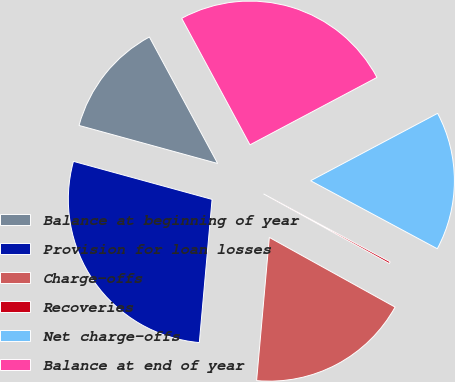Convert chart. <chart><loc_0><loc_0><loc_500><loc_500><pie_chart><fcel>Balance at beginning of year<fcel>Provision for loan losses<fcel>Charge-offs<fcel>Recoveries<fcel>Net charge-offs<fcel>Balance at end of year<nl><fcel>12.86%<fcel>27.85%<fcel>18.36%<fcel>0.21%<fcel>15.61%<fcel>25.11%<nl></chart> 